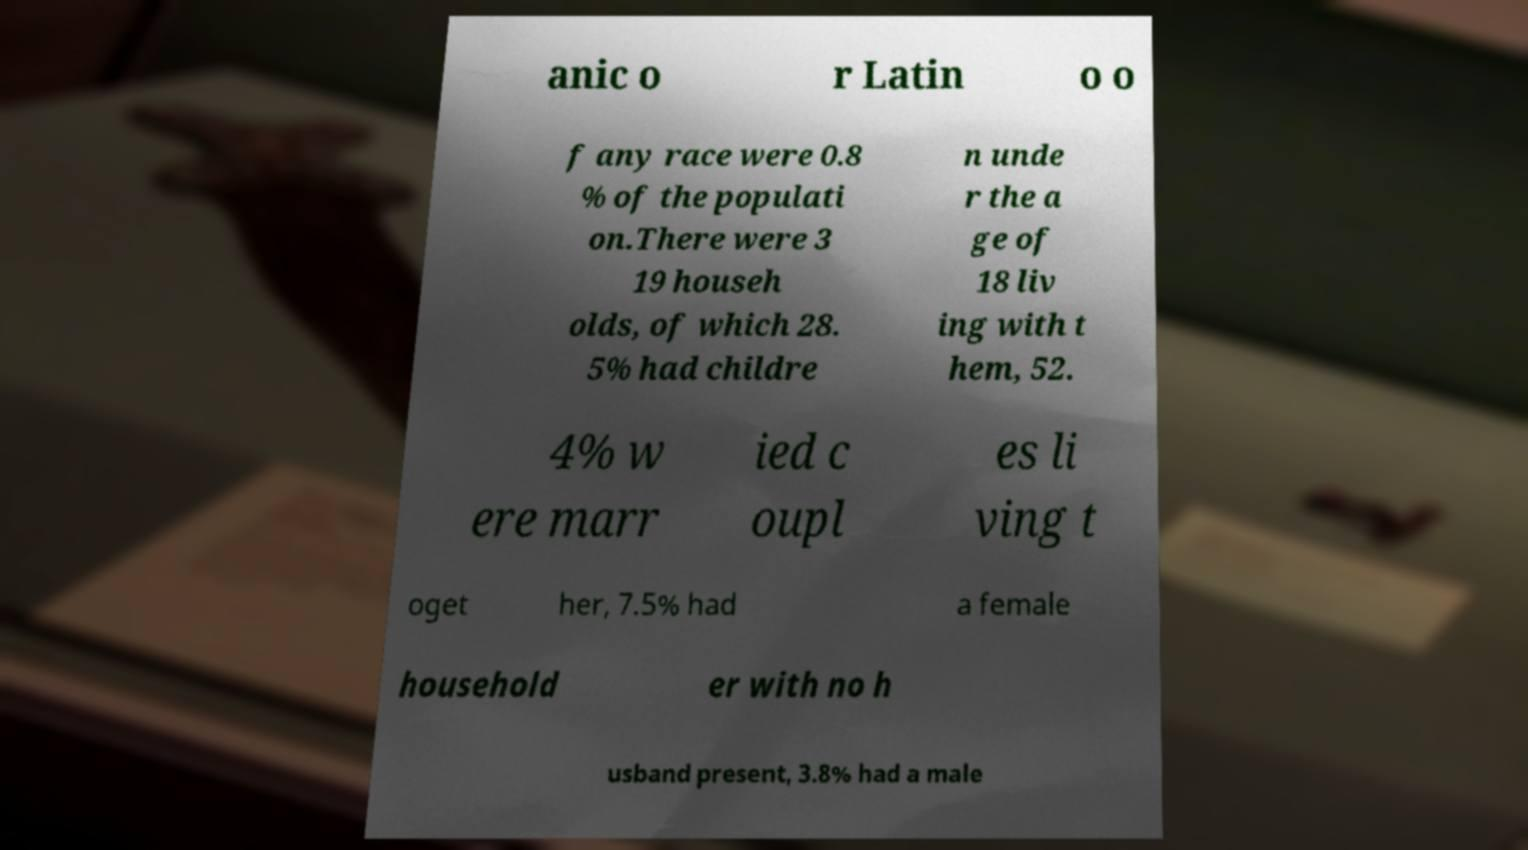What messages or text are displayed in this image? I need them in a readable, typed format. anic o r Latin o o f any race were 0.8 % of the populati on.There were 3 19 househ olds, of which 28. 5% had childre n unde r the a ge of 18 liv ing with t hem, 52. 4% w ere marr ied c oupl es li ving t oget her, 7.5% had a female household er with no h usband present, 3.8% had a male 